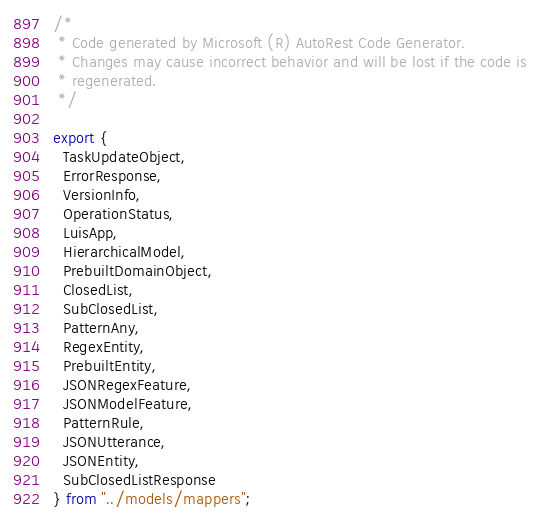<code> <loc_0><loc_0><loc_500><loc_500><_TypeScript_>/*
 * Code generated by Microsoft (R) AutoRest Code Generator.
 * Changes may cause incorrect behavior and will be lost if the code is
 * regenerated.
 */

export {
  TaskUpdateObject,
  ErrorResponse,
  VersionInfo,
  OperationStatus,
  LuisApp,
  HierarchicalModel,
  PrebuiltDomainObject,
  ClosedList,
  SubClosedList,
  PatternAny,
  RegexEntity,
  PrebuiltEntity,
  JSONRegexFeature,
  JSONModelFeature,
  PatternRule,
  JSONUtterance,
  JSONEntity,
  SubClosedListResponse
} from "../models/mappers";

</code> 